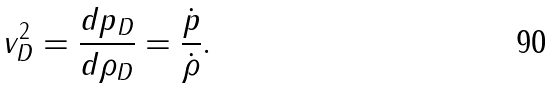Convert formula to latex. <formula><loc_0><loc_0><loc_500><loc_500>v _ { D } ^ { 2 } = \frac { d p _ { D } } { d \rho _ { D } } = \frac { \dot { p } } { \dot { \rho } } .</formula> 